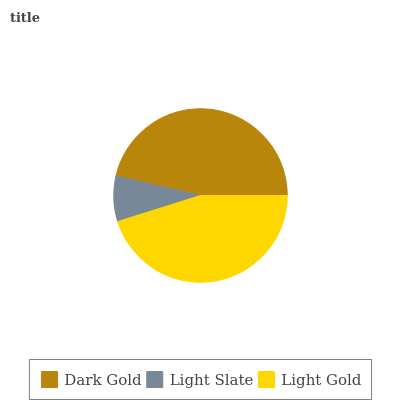Is Light Slate the minimum?
Answer yes or no. Yes. Is Dark Gold the maximum?
Answer yes or no. Yes. Is Light Gold the minimum?
Answer yes or no. No. Is Light Gold the maximum?
Answer yes or no. No. Is Light Gold greater than Light Slate?
Answer yes or no. Yes. Is Light Slate less than Light Gold?
Answer yes or no. Yes. Is Light Slate greater than Light Gold?
Answer yes or no. No. Is Light Gold less than Light Slate?
Answer yes or no. No. Is Light Gold the high median?
Answer yes or no. Yes. Is Light Gold the low median?
Answer yes or no. Yes. Is Light Slate the high median?
Answer yes or no. No. Is Dark Gold the low median?
Answer yes or no. No. 